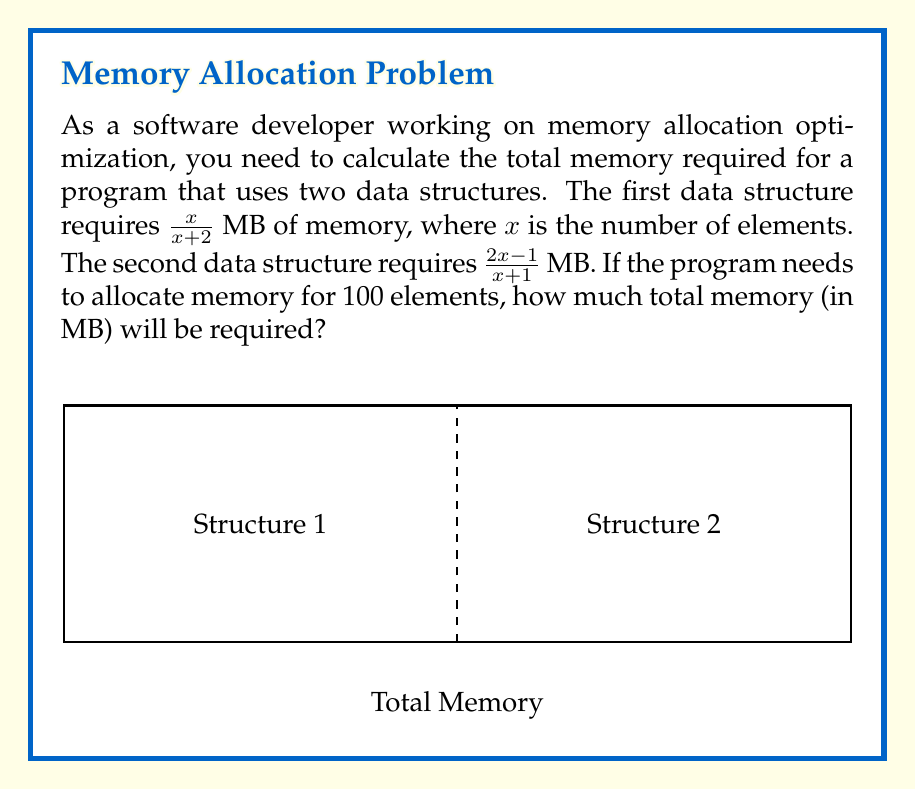Solve this math problem. Let's approach this step-by-step:

1) We need to add the memory requirements of both data structures:

   Total Memory = $\frac{x}{x+2} + \frac{2x-1}{x+1}$

2) We're given that $x = 100$. Let's substitute this:

   Total Memory = $\frac{100}{100+2} + \frac{2(100)-1}{100+1}$

3) Simplify the fractions:
   
   Total Memory = $\frac{100}{102} + \frac{199}{101}$

4) To add these fractions, we need a common denominator. The LCM of 102 and 101 is 10302:

   Total Memory = $\frac{100 \cdot 101}{102 \cdot 101} + \frac{199 \cdot 102}{101 \cdot 102}$

5) Simplify:

   Total Memory = $\frac{10100}{10302} + \frac{20298}{10302}$

6) Now we can add the numerators:

   Total Memory = $\frac{10100 + 20298}{10302} = \frac{30398}{10302}$

7) This fraction can be reduced by dividing both numerator and denominator by 2:

   Total Memory = $\frac{15199}{5151}$

8) This is our final answer, but we can also express it as a decimal:

   Total Memory ≈ 2.9507 MB (rounded to 4 decimal places)
Answer: $\frac{15199}{5151}$ MB or approximately 2.9507 MB 